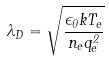<formula> <loc_0><loc_0><loc_500><loc_500>\lambda _ { D } = \sqrt { \frac { \epsilon _ { 0 } k T _ { e } } { n _ { e } q _ { e } ^ { 2 } } }</formula> 